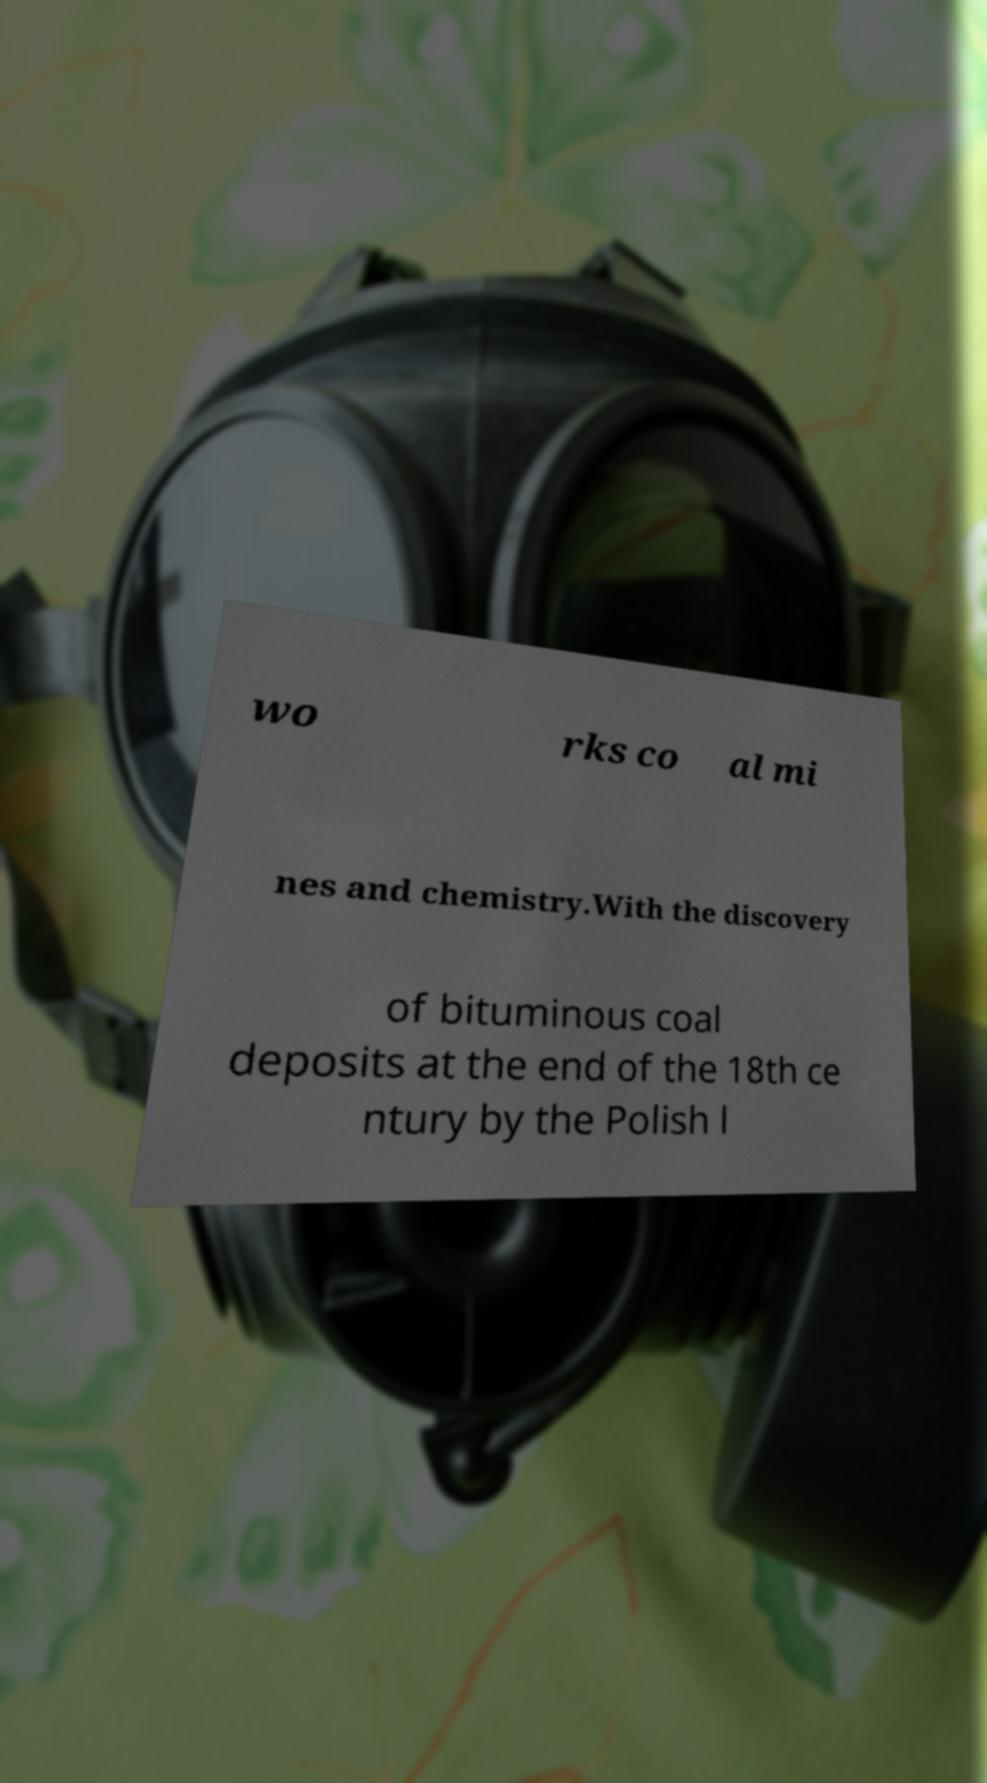Please identify and transcribe the text found in this image. wo rks co al mi nes and chemistry.With the discovery of bituminous coal deposits at the end of the 18th ce ntury by the Polish l 